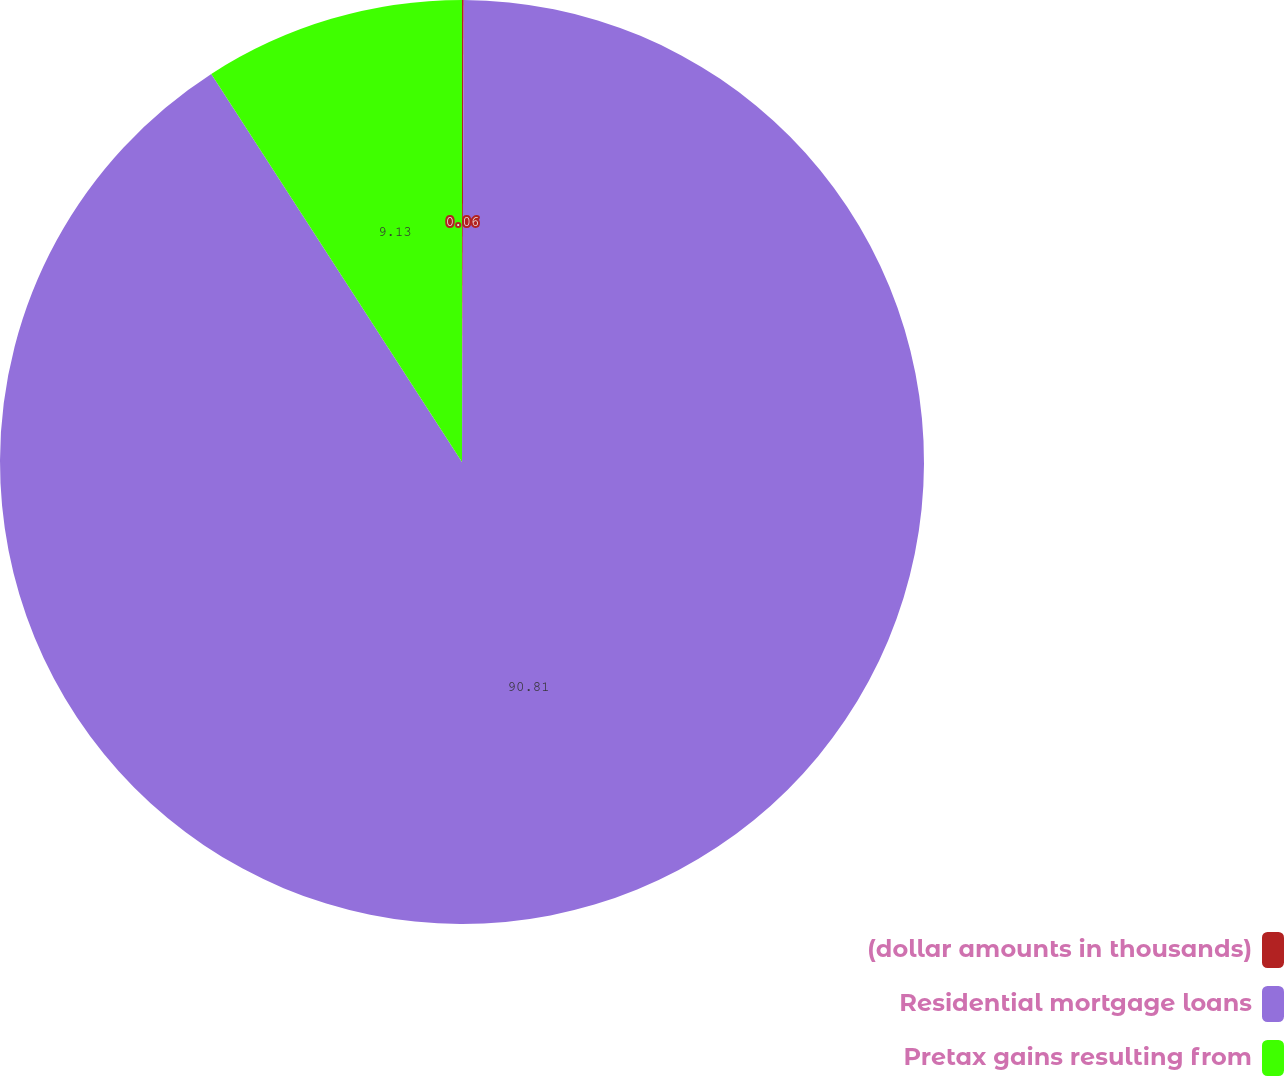Convert chart. <chart><loc_0><loc_0><loc_500><loc_500><pie_chart><fcel>(dollar amounts in thousands)<fcel>Residential mortgage loans<fcel>Pretax gains resulting from<nl><fcel>0.06%<fcel>90.81%<fcel>9.13%<nl></chart> 